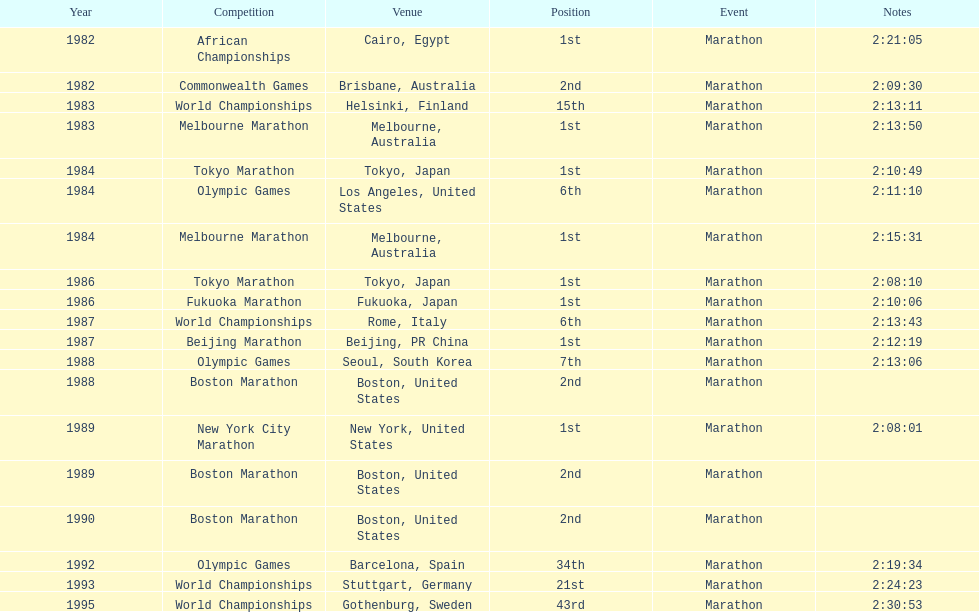Give me the full table as a dictionary. {'header': ['Year', 'Competition', 'Venue', 'Position', 'Event', 'Notes'], 'rows': [['1982', 'African Championships', 'Cairo, Egypt', '1st', 'Marathon', '2:21:05'], ['1982', 'Commonwealth Games', 'Brisbane, Australia', '2nd', 'Marathon', '2:09:30'], ['1983', 'World Championships', 'Helsinki, Finland', '15th', 'Marathon', '2:13:11'], ['1983', 'Melbourne Marathon', 'Melbourne, Australia', '1st', 'Marathon', '2:13:50'], ['1984', 'Tokyo Marathon', 'Tokyo, Japan', '1st', 'Marathon', '2:10:49'], ['1984', 'Olympic Games', 'Los Angeles, United States', '6th', 'Marathon', '2:11:10'], ['1984', 'Melbourne Marathon', 'Melbourne, Australia', '1st', 'Marathon', '2:15:31'], ['1986', 'Tokyo Marathon', 'Tokyo, Japan', '1st', 'Marathon', '2:08:10'], ['1986', 'Fukuoka Marathon', 'Fukuoka, Japan', '1st', 'Marathon', '2:10:06'], ['1987', 'World Championships', 'Rome, Italy', '6th', 'Marathon', '2:13:43'], ['1987', 'Beijing Marathon', 'Beijing, PR China', '1st', 'Marathon', '2:12:19'], ['1988', 'Olympic Games', 'Seoul, South Korea', '7th', 'Marathon', '2:13:06'], ['1988', 'Boston Marathon', 'Boston, United States', '2nd', 'Marathon', ''], ['1989', 'New York City Marathon', 'New York, United States', '1st', 'Marathon', '2:08:01'], ['1989', 'Boston Marathon', 'Boston, United States', '2nd', 'Marathon', ''], ['1990', 'Boston Marathon', 'Boston, United States', '2nd', 'Marathon', ''], ['1992', 'Olympic Games', 'Barcelona, Spain', '34th', 'Marathon', '2:19:34'], ['1993', 'World Championships', 'Stuttgart, Germany', '21st', 'Marathon', '2:24:23'], ['1995', 'World Championships', 'Gothenburg, Sweden', '43rd', 'Marathon', '2:30:53']]} How many times in total did ikangaa run the marathon in the olympic games? 3. 